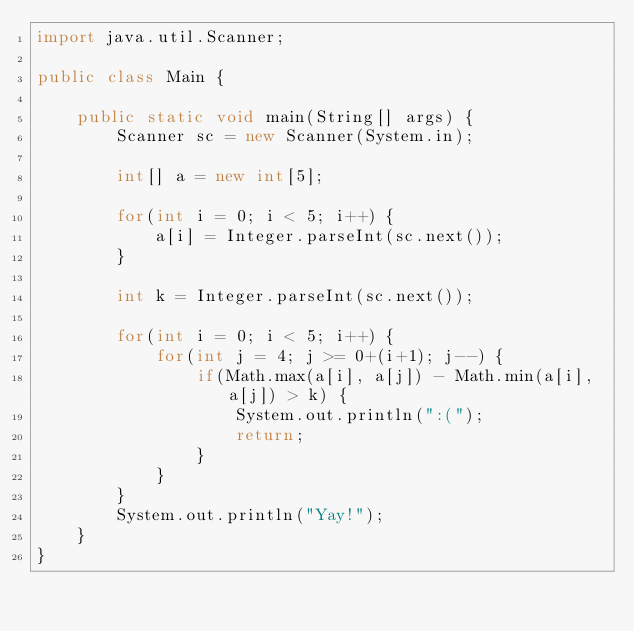<code> <loc_0><loc_0><loc_500><loc_500><_Java_>import java.util.Scanner;

public class Main {

	public static void main(String[] args) {
		Scanner sc = new Scanner(System.in);
		
		int[] a = new int[5];
		
		for(int i = 0; i < 5; i++) {
			a[i] = Integer.parseInt(sc.next());
		}
		
		int k = Integer.parseInt(sc.next());
		
		for(int i = 0; i < 5; i++) {
			for(int j = 4; j >= 0+(i+1); j--) {
				if(Math.max(a[i], a[j]) - Math.min(a[i], a[j]) > k) {
					System.out.println(":(");
					return;
				}
			}
		}
		System.out.println("Yay!");
	}
}
</code> 